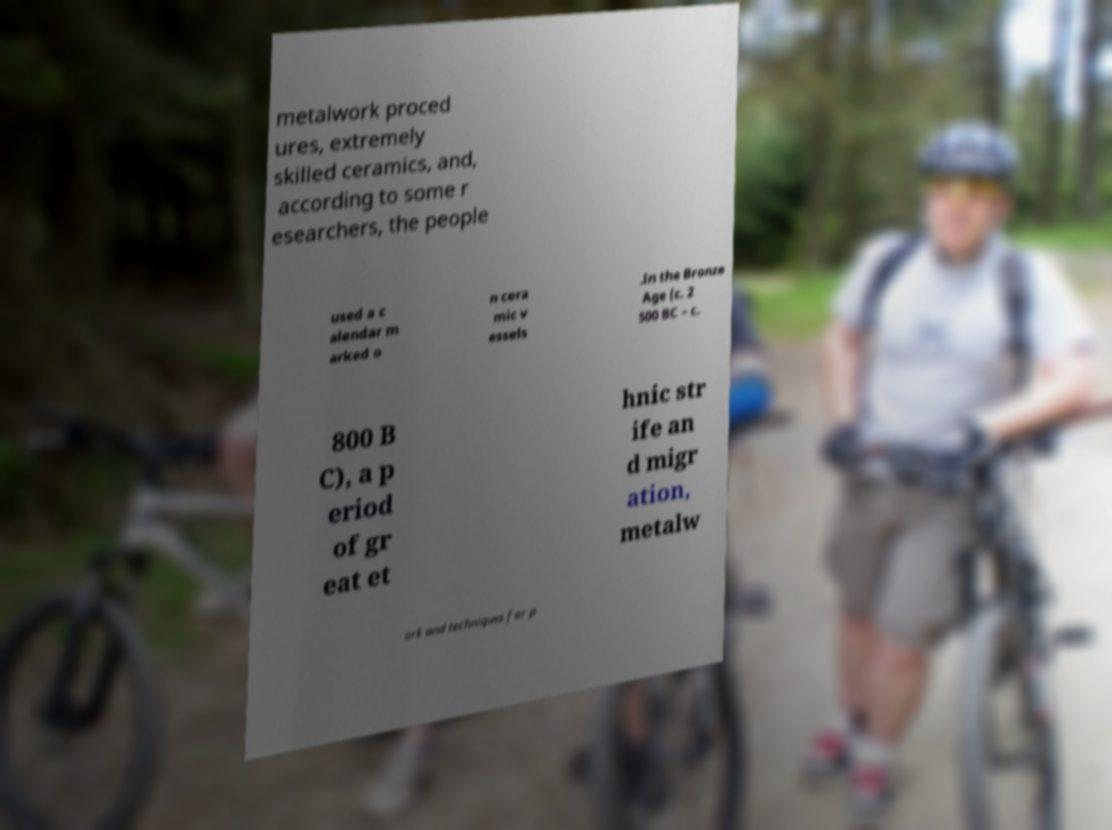Could you extract and type out the text from this image? metalwork proced ures, extremely skilled ceramics, and, according to some r esearchers, the people used a c alendar m arked o n cera mic v essels .In the Bronze Age (c. 2 500 BC – c. 800 B C), a p eriod of gr eat et hnic str ife an d migr ation, metalw ork and techniques for p 